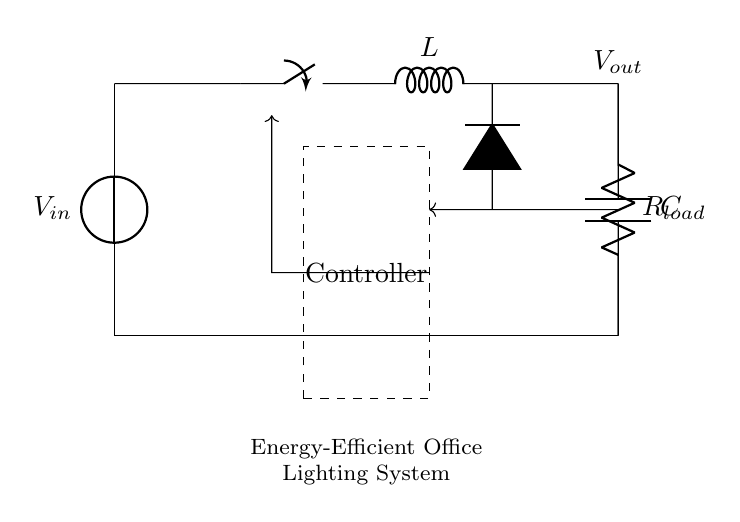What is the input voltage in the circuit? The input voltage is represented as V_in at the power supply section of the diagram.
Answer: V_in What components are present in the circuit? The circuit consists of a voltage source, a switch, an inductor, a diode, a capacitor, a resistor (load), and a controller.
Answer: Voltage source, switch, inductor, diode, capacitor, resistor, controller What is the role of the inductor in this circuit? The inductor stores energy when the switch is closed and releases it when the switch opens, helping regulate the output voltage.
Answer: Energy storage What type of regulator is represented in this circuit? This circuit is a switching regulator, indicated by the presence of a switch and its design to efficiently control voltage.
Answer: Switching regulator How does the feedback loop function in this circuit? The feedback loop provides a control signal from the output to the controller, allowing it to adjust the switching based on the output voltage level.
Answer: Adjusts switching What happens to the output voltage when the load resistance increases? When the load resistance increases, the output voltage may increase initially, but the controller will adjust the switch operation to maintain a stable output voltage.
Answer: Stays stable What is the purpose of the controller in this circuit? The controller regulates the operation of the switch based on feedback from the output voltage to ensure consistent performance.
Answer: Regulation 